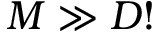Convert formula to latex. <formula><loc_0><loc_0><loc_500><loc_500>M \gg D !</formula> 